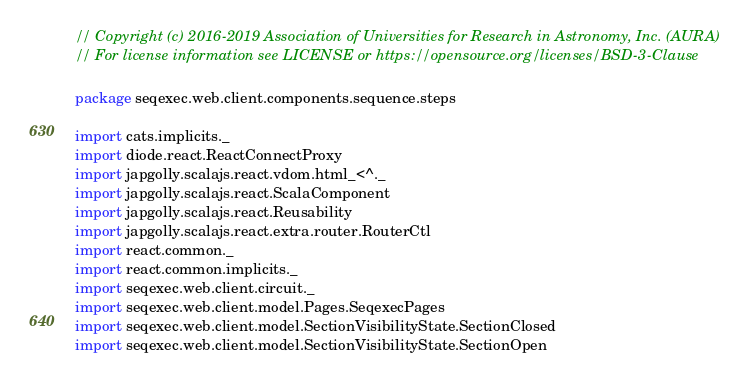<code> <loc_0><loc_0><loc_500><loc_500><_Scala_>// Copyright (c) 2016-2019 Association of Universities for Research in Astronomy, Inc. (AURA)
// For license information see LICENSE or https://opensource.org/licenses/BSD-3-Clause

package seqexec.web.client.components.sequence.steps

import cats.implicits._
import diode.react.ReactConnectProxy
import japgolly.scalajs.react.vdom.html_<^._
import japgolly.scalajs.react.ScalaComponent
import japgolly.scalajs.react.Reusability
import japgolly.scalajs.react.extra.router.RouterCtl
import react.common._
import react.common.implicits._
import seqexec.web.client.circuit._
import seqexec.web.client.model.Pages.SeqexecPages
import seqexec.web.client.model.SectionVisibilityState.SectionClosed
import seqexec.web.client.model.SectionVisibilityState.SectionOpen</code> 